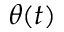<formula> <loc_0><loc_0><loc_500><loc_500>\theta ( t )</formula> 